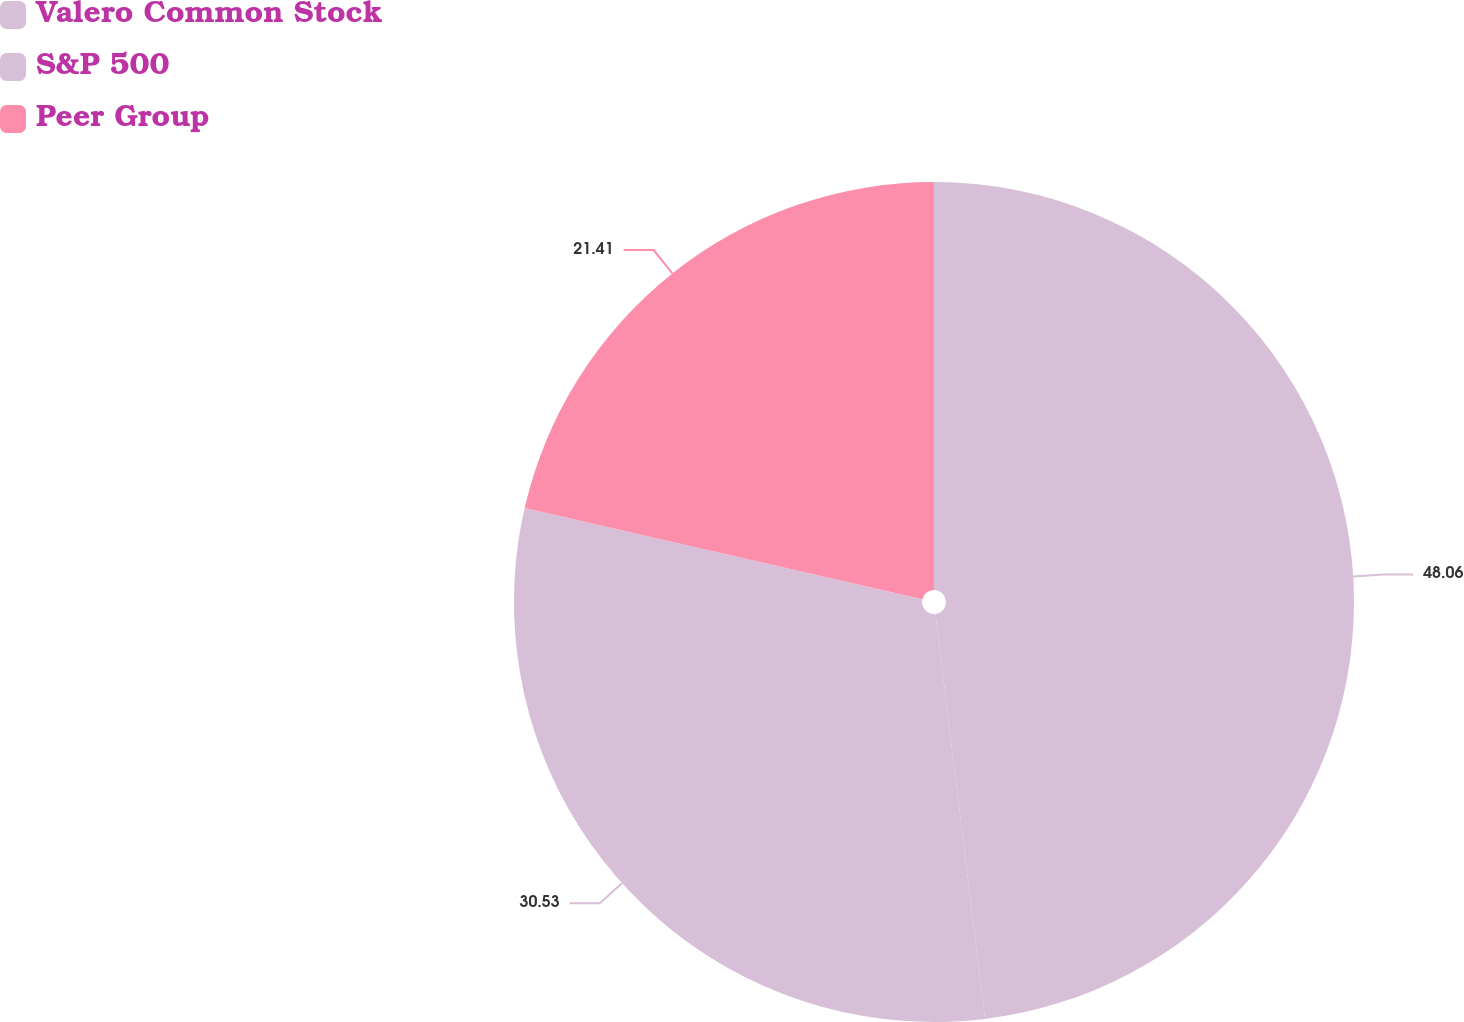<chart> <loc_0><loc_0><loc_500><loc_500><pie_chart><fcel>Valero Common Stock<fcel>S&P 500<fcel>Peer Group<nl><fcel>48.06%<fcel>30.53%<fcel>21.41%<nl></chart> 